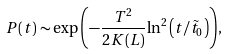<formula> <loc_0><loc_0><loc_500><loc_500>P ( t ) \sim \exp { \left ( - \frac { T ^ { 2 } } { 2 K ( L ) } { \ln ^ { 2 } { \left ( { t } / { { \tilde { t } } _ { 0 } } \right ) } } \right ) } ,</formula> 